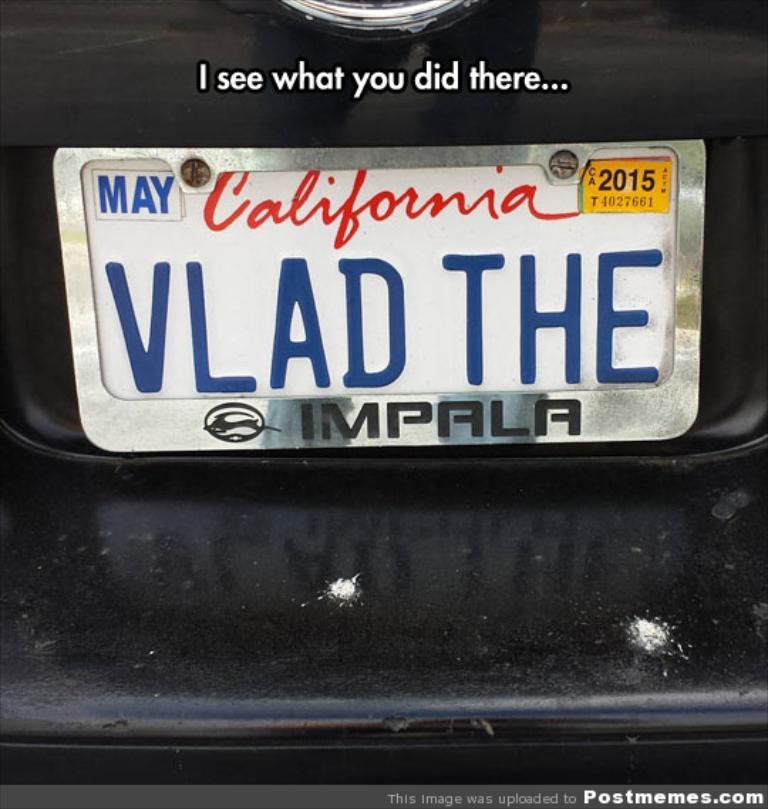Are they from california?
Keep it short and to the point. Yes. 